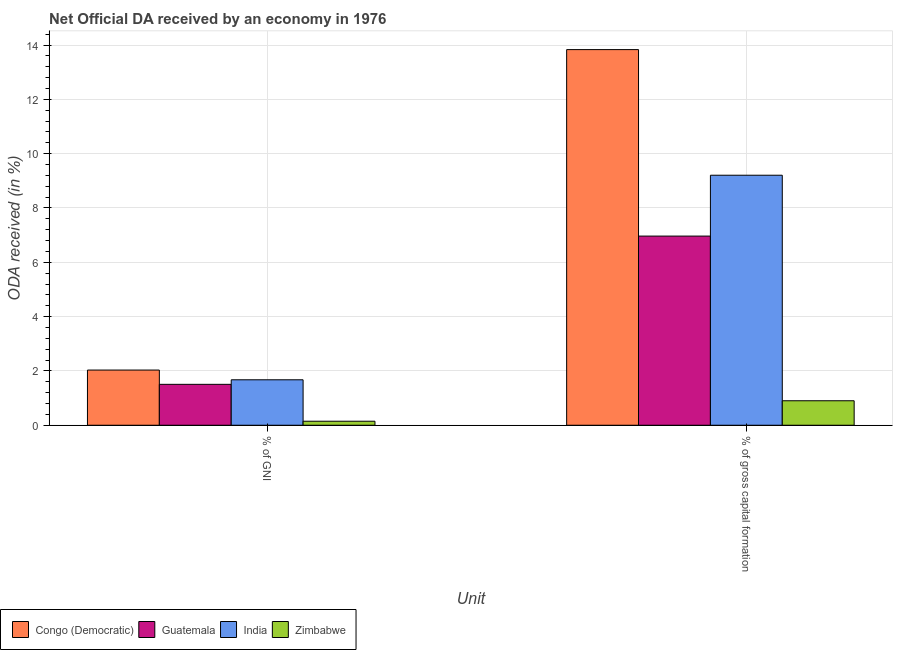How many different coloured bars are there?
Provide a succinct answer. 4. Are the number of bars per tick equal to the number of legend labels?
Provide a short and direct response. Yes. Are the number of bars on each tick of the X-axis equal?
Your answer should be compact. Yes. How many bars are there on the 2nd tick from the left?
Make the answer very short. 4. What is the label of the 1st group of bars from the left?
Ensure brevity in your answer.  % of GNI. What is the oda received as percentage of gross capital formation in Guatemala?
Give a very brief answer. 6.96. Across all countries, what is the maximum oda received as percentage of gross capital formation?
Your answer should be compact. 13.83. Across all countries, what is the minimum oda received as percentage of gross capital formation?
Ensure brevity in your answer.  0.9. In which country was the oda received as percentage of gni maximum?
Offer a very short reply. Congo (Democratic). In which country was the oda received as percentage of gni minimum?
Make the answer very short. Zimbabwe. What is the total oda received as percentage of gni in the graph?
Your answer should be very brief. 5.36. What is the difference between the oda received as percentage of gni in Congo (Democratic) and that in Guatemala?
Make the answer very short. 0.53. What is the difference between the oda received as percentage of gross capital formation in Zimbabwe and the oda received as percentage of gni in Congo (Democratic)?
Your response must be concise. -1.13. What is the average oda received as percentage of gni per country?
Offer a terse response. 1.34. What is the difference between the oda received as percentage of gross capital formation and oda received as percentage of gni in Congo (Democratic)?
Make the answer very short. 11.8. What is the ratio of the oda received as percentage of gross capital formation in Congo (Democratic) to that in Guatemala?
Keep it short and to the point. 1.99. Is the oda received as percentage of gross capital formation in Guatemala less than that in Congo (Democratic)?
Keep it short and to the point. Yes. What does the 2nd bar from the left in % of GNI represents?
Your answer should be compact. Guatemala. What does the 1st bar from the right in % of gross capital formation represents?
Make the answer very short. Zimbabwe. How many bars are there?
Offer a very short reply. 8. Does the graph contain grids?
Your response must be concise. Yes. How are the legend labels stacked?
Your response must be concise. Horizontal. What is the title of the graph?
Provide a succinct answer. Net Official DA received by an economy in 1976. What is the label or title of the X-axis?
Your response must be concise. Unit. What is the label or title of the Y-axis?
Offer a very short reply. ODA received (in %). What is the ODA received (in %) of Congo (Democratic) in % of GNI?
Your answer should be compact. 2.03. What is the ODA received (in %) in Guatemala in % of GNI?
Ensure brevity in your answer.  1.51. What is the ODA received (in %) of India in % of GNI?
Give a very brief answer. 1.67. What is the ODA received (in %) in Zimbabwe in % of GNI?
Offer a terse response. 0.15. What is the ODA received (in %) in Congo (Democratic) in % of gross capital formation?
Your answer should be compact. 13.83. What is the ODA received (in %) in Guatemala in % of gross capital formation?
Your response must be concise. 6.96. What is the ODA received (in %) in India in % of gross capital formation?
Ensure brevity in your answer.  9.21. What is the ODA received (in %) of Zimbabwe in % of gross capital formation?
Provide a short and direct response. 0.9. Across all Unit, what is the maximum ODA received (in %) of Congo (Democratic)?
Your response must be concise. 13.83. Across all Unit, what is the maximum ODA received (in %) in Guatemala?
Offer a terse response. 6.96. Across all Unit, what is the maximum ODA received (in %) in India?
Ensure brevity in your answer.  9.21. Across all Unit, what is the maximum ODA received (in %) in Zimbabwe?
Your response must be concise. 0.9. Across all Unit, what is the minimum ODA received (in %) in Congo (Democratic)?
Offer a terse response. 2.03. Across all Unit, what is the minimum ODA received (in %) of Guatemala?
Make the answer very short. 1.51. Across all Unit, what is the minimum ODA received (in %) of India?
Provide a short and direct response. 1.67. Across all Unit, what is the minimum ODA received (in %) of Zimbabwe?
Make the answer very short. 0.15. What is the total ODA received (in %) of Congo (Democratic) in the graph?
Provide a succinct answer. 15.86. What is the total ODA received (in %) of Guatemala in the graph?
Your answer should be compact. 8.47. What is the total ODA received (in %) of India in the graph?
Provide a succinct answer. 10.88. What is the total ODA received (in %) of Zimbabwe in the graph?
Provide a succinct answer. 1.05. What is the difference between the ODA received (in %) of Congo (Democratic) in % of GNI and that in % of gross capital formation?
Your response must be concise. -11.8. What is the difference between the ODA received (in %) of Guatemala in % of GNI and that in % of gross capital formation?
Give a very brief answer. -5.46. What is the difference between the ODA received (in %) of India in % of GNI and that in % of gross capital formation?
Provide a short and direct response. -7.53. What is the difference between the ODA received (in %) in Zimbabwe in % of GNI and that in % of gross capital formation?
Offer a terse response. -0.75. What is the difference between the ODA received (in %) of Congo (Democratic) in % of GNI and the ODA received (in %) of Guatemala in % of gross capital formation?
Ensure brevity in your answer.  -4.93. What is the difference between the ODA received (in %) in Congo (Democratic) in % of GNI and the ODA received (in %) in India in % of gross capital formation?
Your response must be concise. -7.17. What is the difference between the ODA received (in %) in Congo (Democratic) in % of GNI and the ODA received (in %) in Zimbabwe in % of gross capital formation?
Offer a terse response. 1.13. What is the difference between the ODA received (in %) in Guatemala in % of GNI and the ODA received (in %) in India in % of gross capital formation?
Make the answer very short. -7.7. What is the difference between the ODA received (in %) in Guatemala in % of GNI and the ODA received (in %) in Zimbabwe in % of gross capital formation?
Your answer should be very brief. 0.6. What is the difference between the ODA received (in %) of India in % of GNI and the ODA received (in %) of Zimbabwe in % of gross capital formation?
Keep it short and to the point. 0.77. What is the average ODA received (in %) of Congo (Democratic) per Unit?
Make the answer very short. 7.93. What is the average ODA received (in %) in Guatemala per Unit?
Offer a very short reply. 4.24. What is the average ODA received (in %) of India per Unit?
Your answer should be compact. 5.44. What is the average ODA received (in %) in Zimbabwe per Unit?
Provide a succinct answer. 0.52. What is the difference between the ODA received (in %) in Congo (Democratic) and ODA received (in %) in Guatemala in % of GNI?
Provide a succinct answer. 0.53. What is the difference between the ODA received (in %) in Congo (Democratic) and ODA received (in %) in India in % of GNI?
Ensure brevity in your answer.  0.36. What is the difference between the ODA received (in %) of Congo (Democratic) and ODA received (in %) of Zimbabwe in % of GNI?
Provide a short and direct response. 1.88. What is the difference between the ODA received (in %) of Guatemala and ODA received (in %) of India in % of GNI?
Keep it short and to the point. -0.17. What is the difference between the ODA received (in %) of Guatemala and ODA received (in %) of Zimbabwe in % of GNI?
Keep it short and to the point. 1.36. What is the difference between the ODA received (in %) of India and ODA received (in %) of Zimbabwe in % of GNI?
Provide a succinct answer. 1.53. What is the difference between the ODA received (in %) of Congo (Democratic) and ODA received (in %) of Guatemala in % of gross capital formation?
Make the answer very short. 6.87. What is the difference between the ODA received (in %) in Congo (Democratic) and ODA received (in %) in India in % of gross capital formation?
Give a very brief answer. 4.63. What is the difference between the ODA received (in %) in Congo (Democratic) and ODA received (in %) in Zimbabwe in % of gross capital formation?
Your answer should be very brief. 12.93. What is the difference between the ODA received (in %) of Guatemala and ODA received (in %) of India in % of gross capital formation?
Offer a very short reply. -2.24. What is the difference between the ODA received (in %) of Guatemala and ODA received (in %) of Zimbabwe in % of gross capital formation?
Make the answer very short. 6.06. What is the difference between the ODA received (in %) of India and ODA received (in %) of Zimbabwe in % of gross capital formation?
Provide a short and direct response. 8.3. What is the ratio of the ODA received (in %) of Congo (Democratic) in % of GNI to that in % of gross capital formation?
Your answer should be very brief. 0.15. What is the ratio of the ODA received (in %) of Guatemala in % of GNI to that in % of gross capital formation?
Your answer should be compact. 0.22. What is the ratio of the ODA received (in %) of India in % of GNI to that in % of gross capital formation?
Your response must be concise. 0.18. What is the ratio of the ODA received (in %) in Zimbabwe in % of GNI to that in % of gross capital formation?
Provide a succinct answer. 0.16. What is the difference between the highest and the second highest ODA received (in %) of Congo (Democratic)?
Offer a terse response. 11.8. What is the difference between the highest and the second highest ODA received (in %) in Guatemala?
Your answer should be compact. 5.46. What is the difference between the highest and the second highest ODA received (in %) in India?
Keep it short and to the point. 7.53. What is the difference between the highest and the second highest ODA received (in %) in Zimbabwe?
Your response must be concise. 0.75. What is the difference between the highest and the lowest ODA received (in %) of Congo (Democratic)?
Give a very brief answer. 11.8. What is the difference between the highest and the lowest ODA received (in %) in Guatemala?
Ensure brevity in your answer.  5.46. What is the difference between the highest and the lowest ODA received (in %) in India?
Offer a very short reply. 7.53. What is the difference between the highest and the lowest ODA received (in %) of Zimbabwe?
Offer a very short reply. 0.75. 